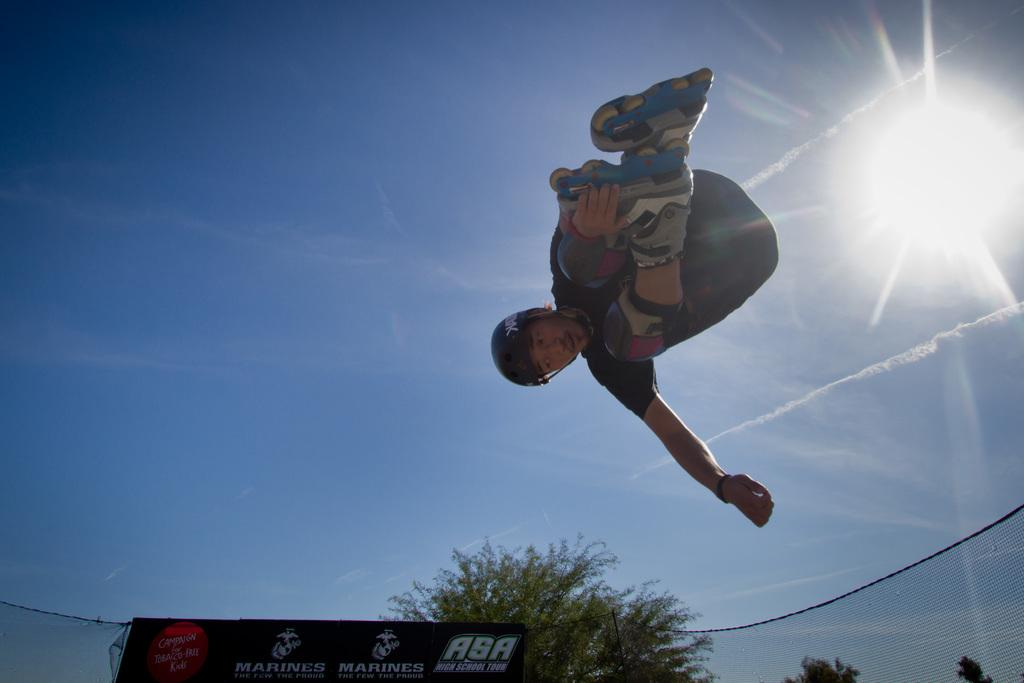What is happening in the image involving a person? The person in the image is jumping in the air. What can be seen in the background of the image? There is a banner and trees in the background of the image. What is the condition of the sky in the image? The sun is visible in the sky, indicating a clear day. Is the person driving a car in the image? No, the person is not driving a car in the image; they are jumping in the air. Can you see a match being lit in the image? No, there is no match or any indication of fire in the image. 